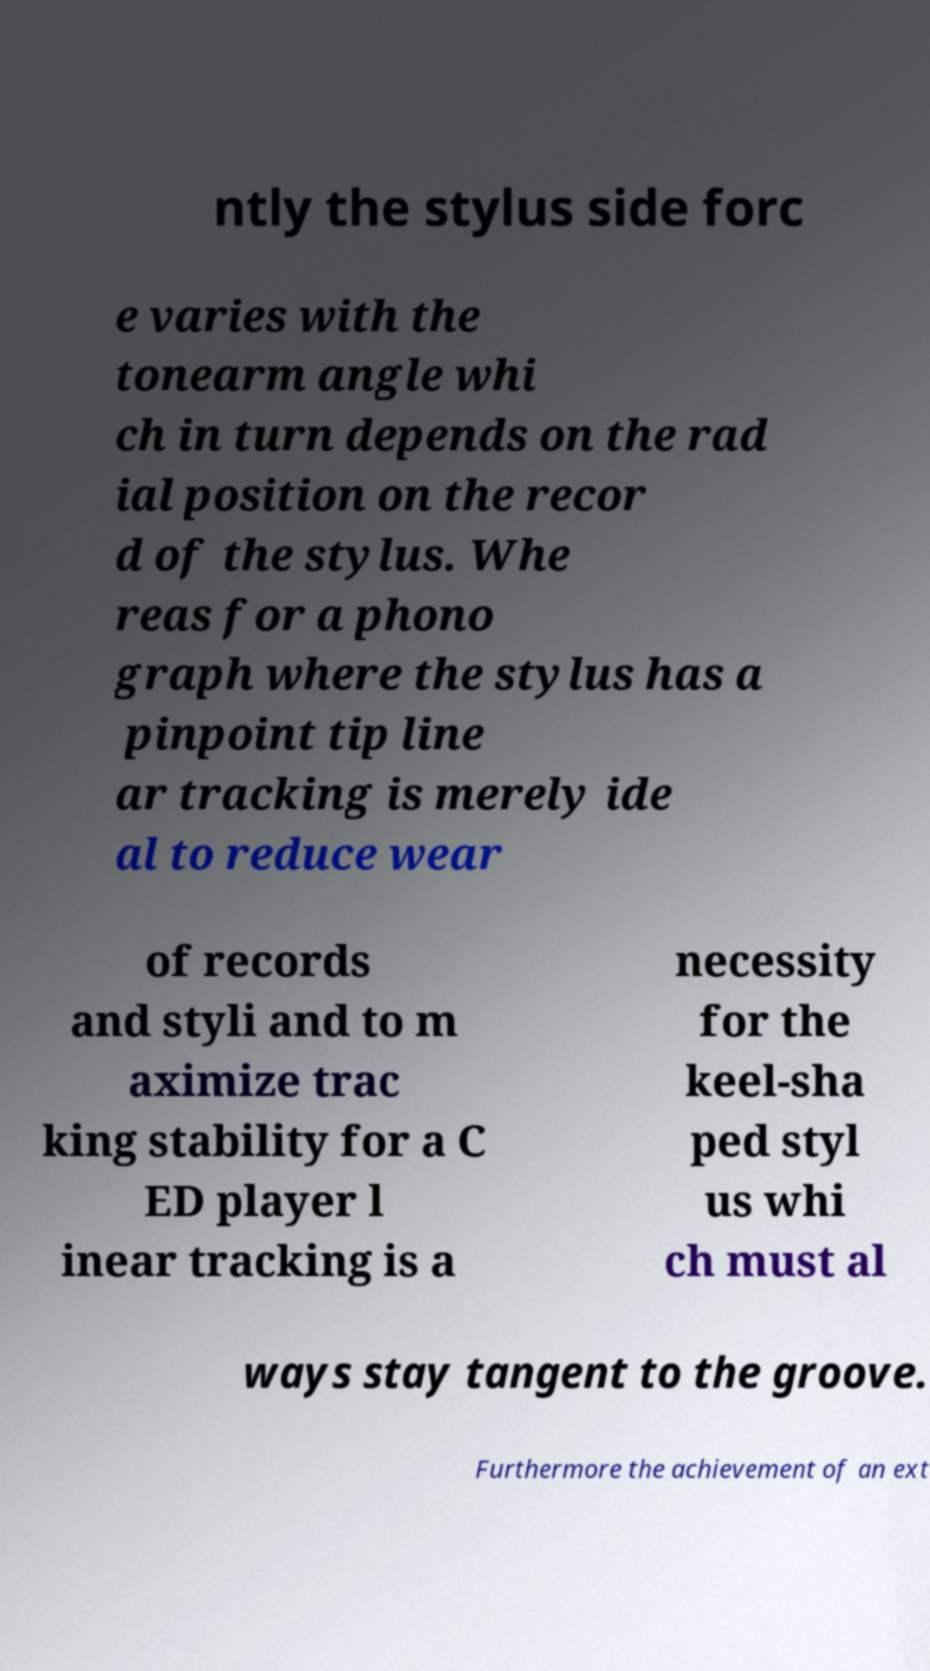Can you accurately transcribe the text from the provided image for me? ntly the stylus side forc e varies with the tonearm angle whi ch in turn depends on the rad ial position on the recor d of the stylus. Whe reas for a phono graph where the stylus has a pinpoint tip line ar tracking is merely ide al to reduce wear of records and styli and to m aximize trac king stability for a C ED player l inear tracking is a necessity for the keel-sha ped styl us whi ch must al ways stay tangent to the groove. Furthermore the achievement of an ext 